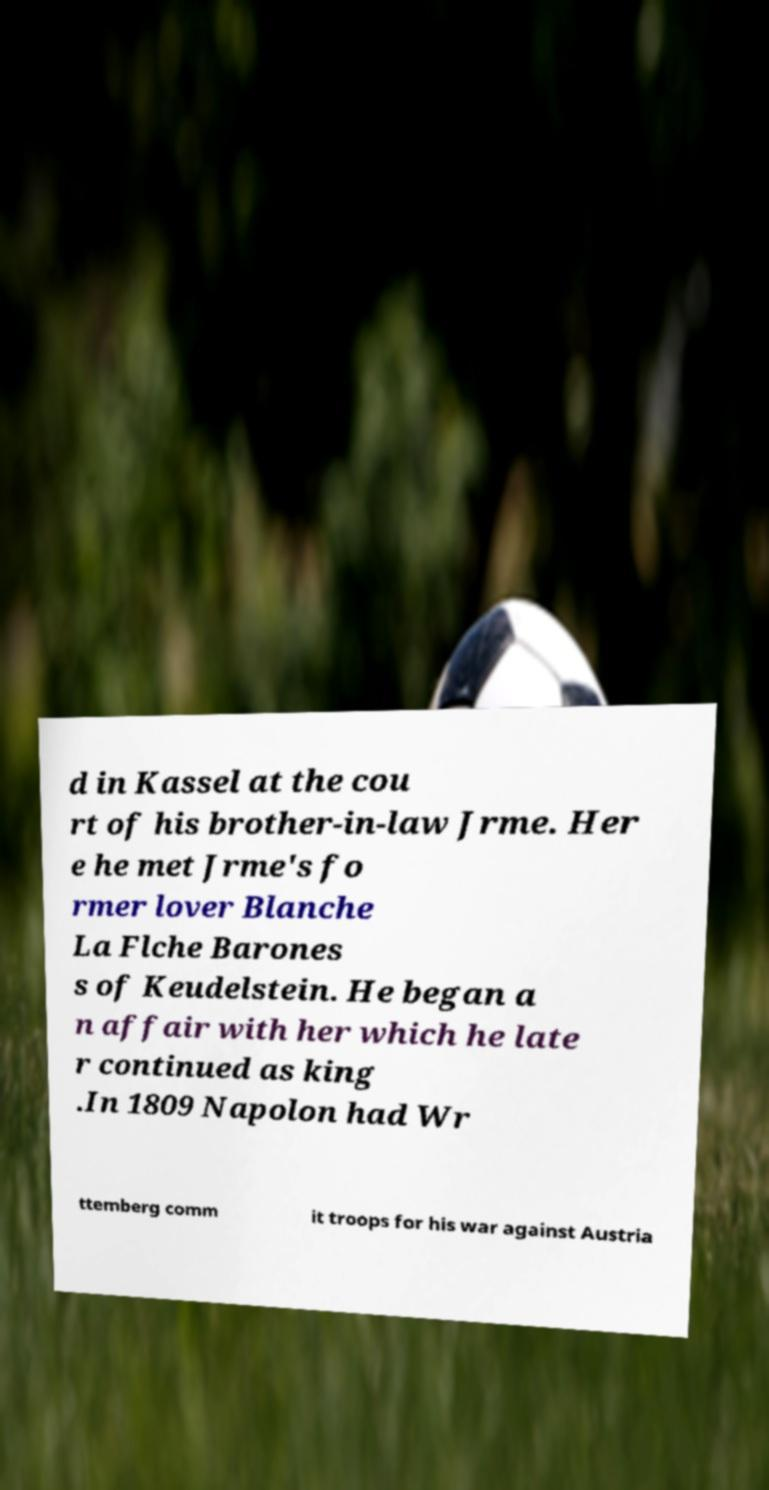I need the written content from this picture converted into text. Can you do that? d in Kassel at the cou rt of his brother-in-law Jrme. Her e he met Jrme's fo rmer lover Blanche La Flche Barones s of Keudelstein. He began a n affair with her which he late r continued as king .In 1809 Napolon had Wr ttemberg comm it troops for his war against Austria 